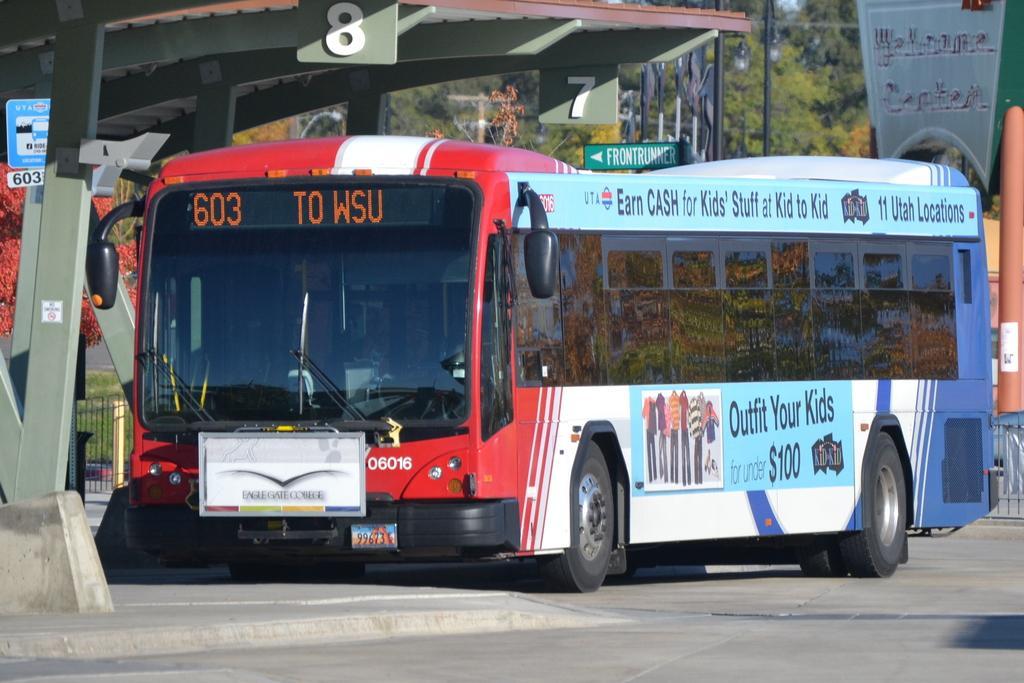Could you give a brief overview of what you see in this image? In this picture we can see a bus, beside to the bus we can find few sign boards and a shelter, in the background we can find few metal rods and trees. 